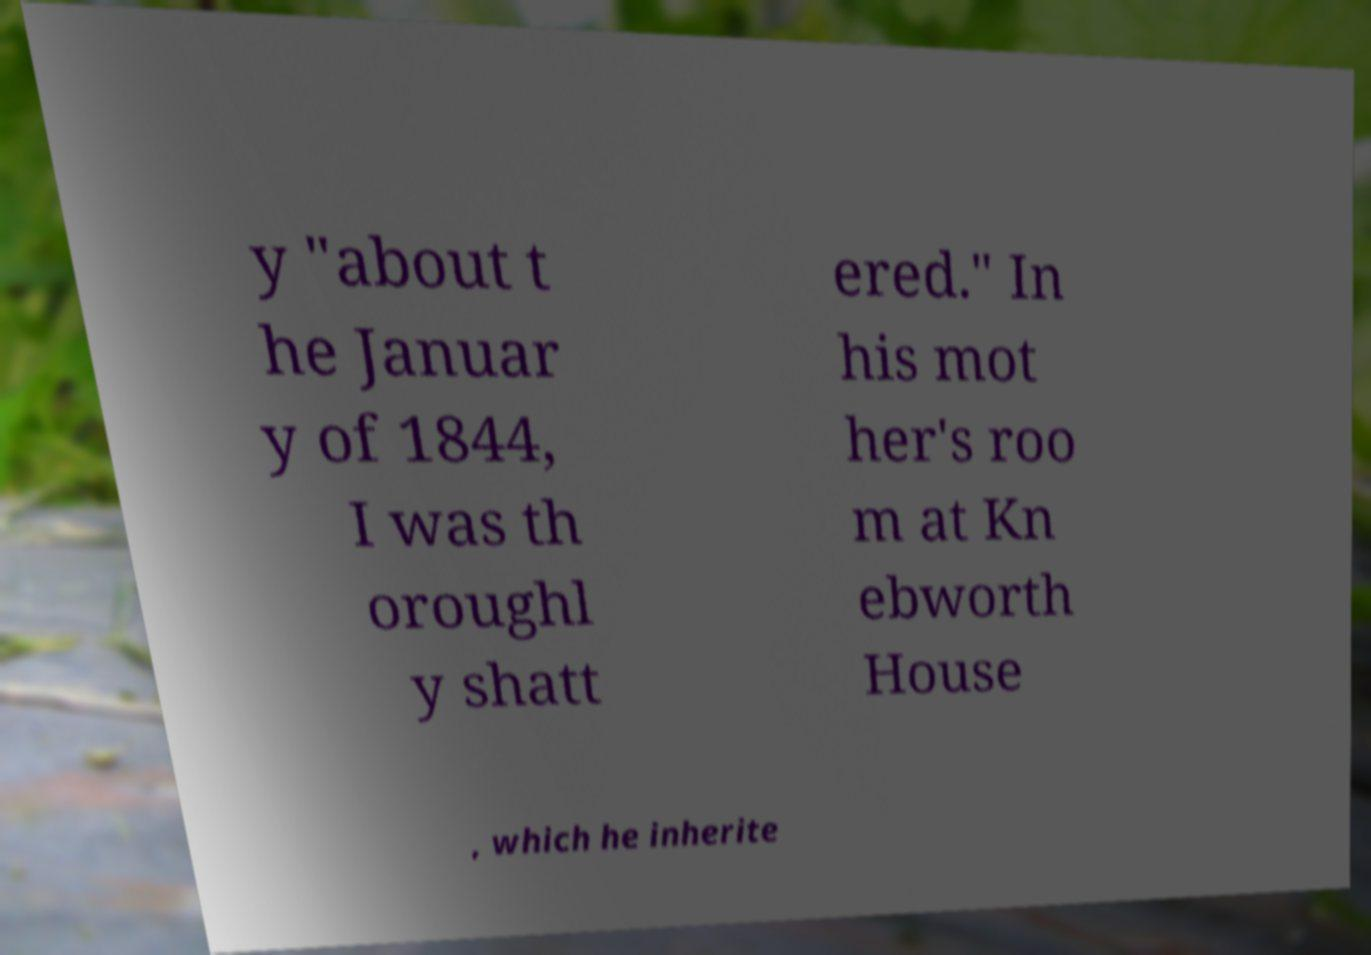Please identify and transcribe the text found in this image. y "about t he Januar y of 1844, I was th oroughl y shatt ered." In his mot her's roo m at Kn ebworth House , which he inherite 